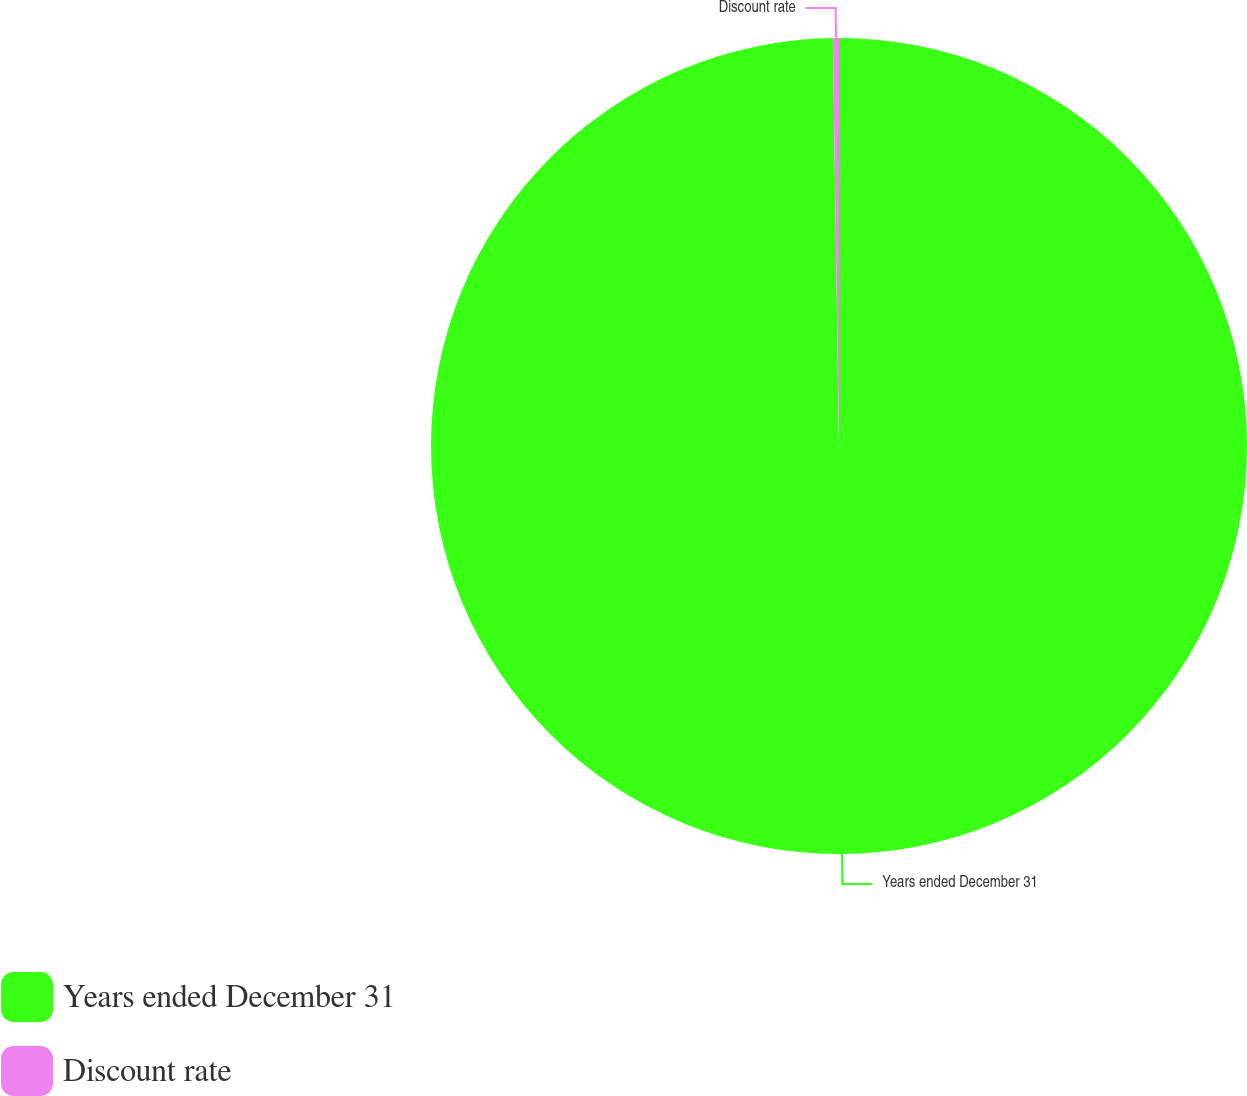Convert chart. <chart><loc_0><loc_0><loc_500><loc_500><pie_chart><fcel>Years ended December 31<fcel>Discount rate<nl><fcel>99.76%<fcel>0.24%<nl></chart> 